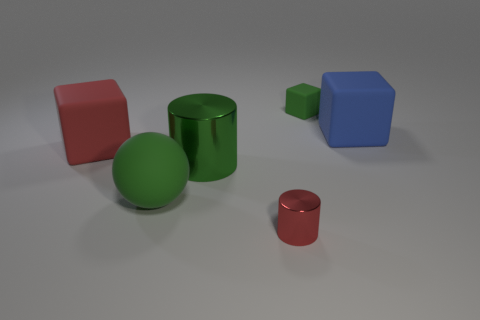Do the green matte sphere and the metal cylinder left of the tiny red metal cylinder have the same size? yes 